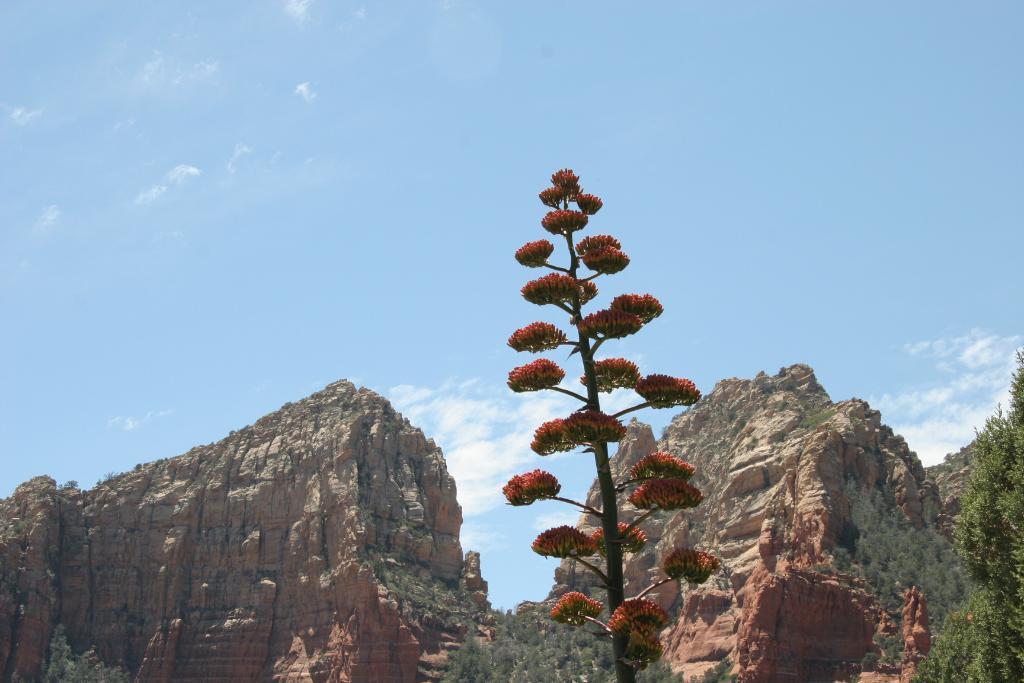Can you describe this image briefly? In the center of the image, we can see a plant and in the background, there are mountains and on the right, there is a tree. 